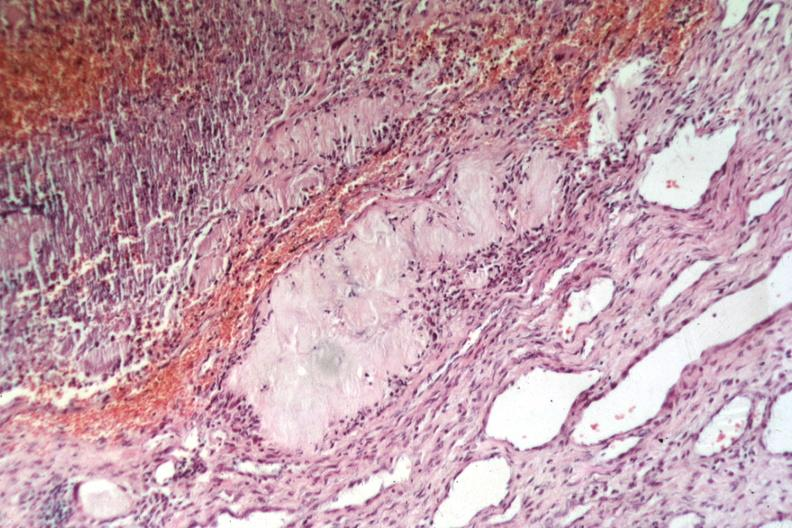what does this image show?
Answer the question using a single word or phrase. Easily recognized uric acid deposit lesion from elbow 